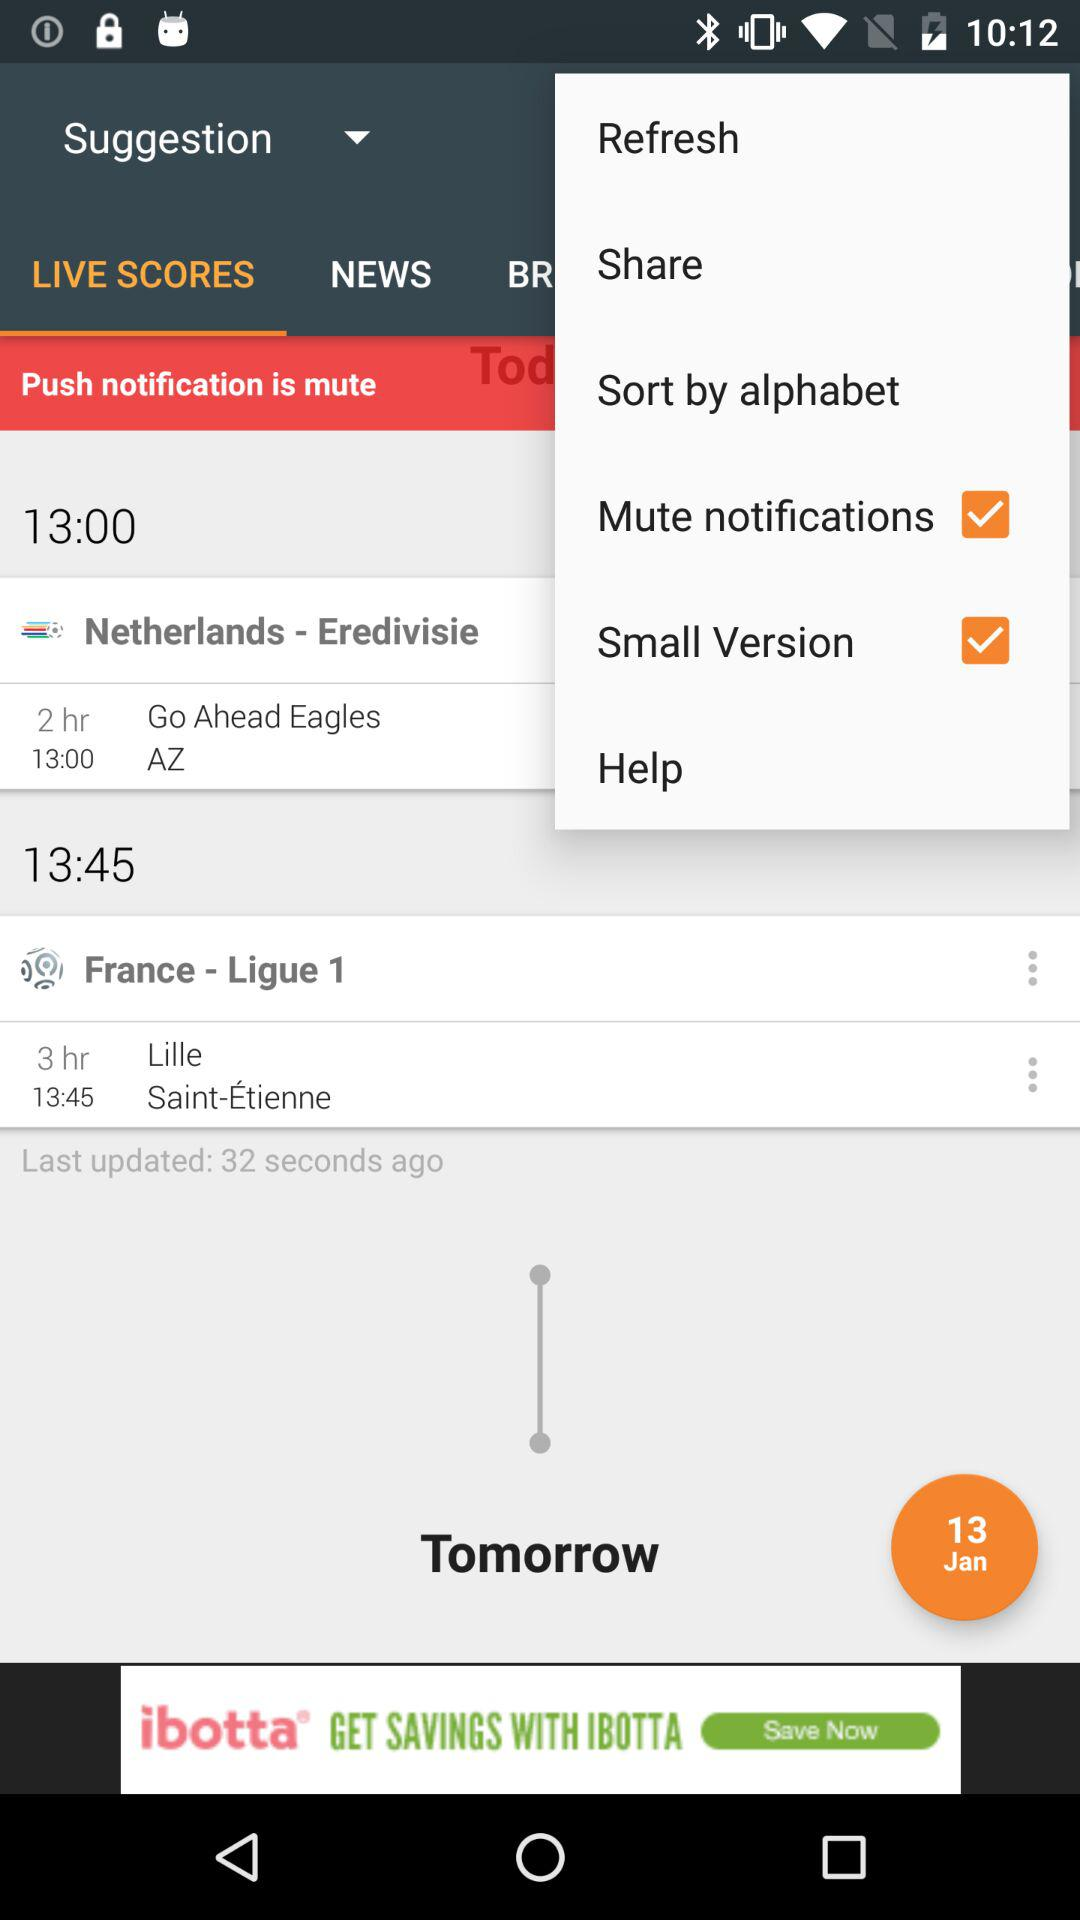What is the match time for "Netherlands - Eredivisie"? The match time for "Netherlands - Eredivisie" is 13:00. 